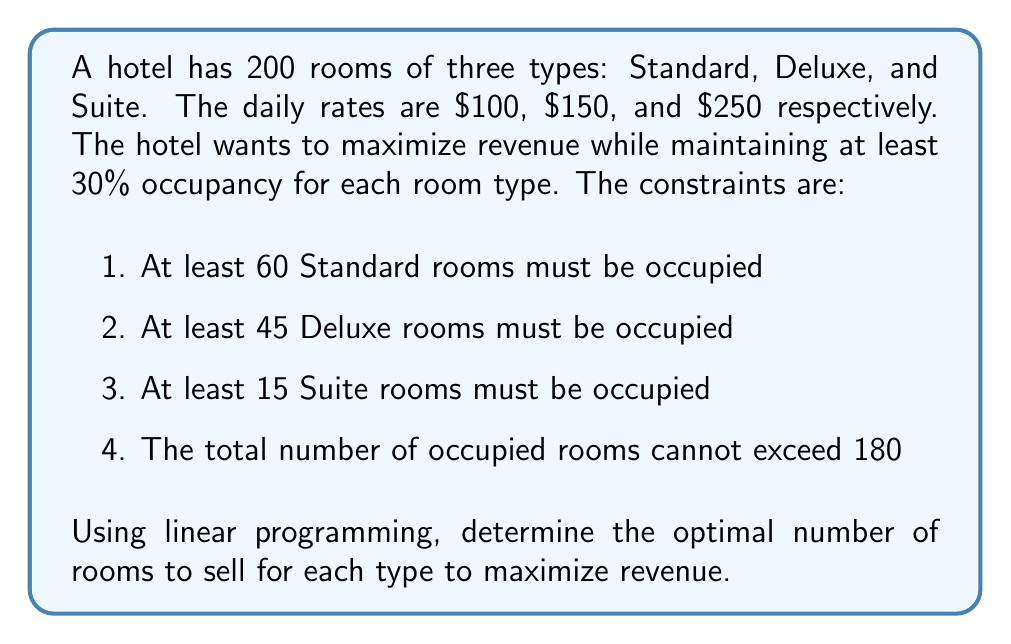Give your solution to this math problem. Let's solve this step-by-step using linear programming:

1. Define variables:
   $x$ = number of Standard rooms sold
   $y$ = number of Deluxe rooms sold
   $z$ = number of Suite rooms sold

2. Objective function (maximize revenue):
   $\text{Maximize } R = 100x + 150y + 250z$

3. Constraints:
   a) Minimum occupancy for each room type:
      $x \geq 60$
      $y \geq 45$
      $z \geq 15$

   b) Maximum total occupancy:
      $x + y + z \leq 180$

   c) Non-negativity:
      $x, y, z \geq 0$

4. Solve using the simplex method or linear programming software:

   The optimal solution is:
   $x = 60$ (Standard rooms)
   $y = 45$ (Deluxe rooms)
   $z = 75$ (Suite rooms)

5. Verify constraints:
   a) $60 \geq 60$, $45 \geq 45$, $75 \geq 15$ (Satisfied)
   b) $60 + 45 + 75 = 180 \leq 180$ (Satisfied)

6. Calculate maximum revenue:
   $R = 100(60) + 150(45) + 250(75) = 6000 + 6750 + 18750 = 31500$

Therefore, the optimal strategy is to sell 60 Standard rooms, 45 Deluxe rooms, and 75 Suite rooms, resulting in a maximum daily revenue of $31,500.
Answer: Standard: 60, Deluxe: 45, Suite: 75; Revenue: $31,500 